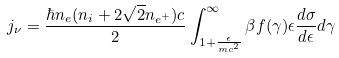Convert formula to latex. <formula><loc_0><loc_0><loc_500><loc_500>j _ { \nu } = \frac { \hbar { n } _ { e } ( n _ { i } + 2 \sqrt { 2 } n _ { e ^ { + } } ) c } { 2 } \int ^ { \infty } _ { 1 + \frac { \epsilon } { m c ^ { 2 } } } \beta f ( \gamma ) \epsilon \frac { d \sigma } { d \epsilon } d \gamma</formula> 